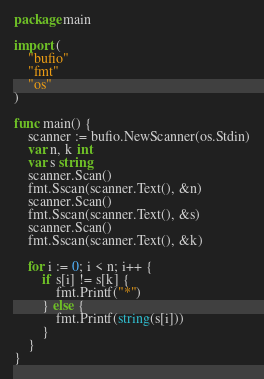Convert code to text. <code><loc_0><loc_0><loc_500><loc_500><_Go_>package main

import (
	"bufio"
	"fmt"
	"os"
)

func main() {
	scanner := bufio.NewScanner(os.Stdin)
	var n, k int
	var s string
	scanner.Scan()
	fmt.Sscan(scanner.Text(), &n)
	scanner.Scan()
	fmt.Sscan(scanner.Text(), &s)
	scanner.Scan()
	fmt.Sscan(scanner.Text(), &k)

	for i := 0; i < n; i++ {
		if s[i] != s[k] {
			fmt.Printf("*")
		} else {
			fmt.Printf(string(s[i]))
		}
	}
}
</code> 